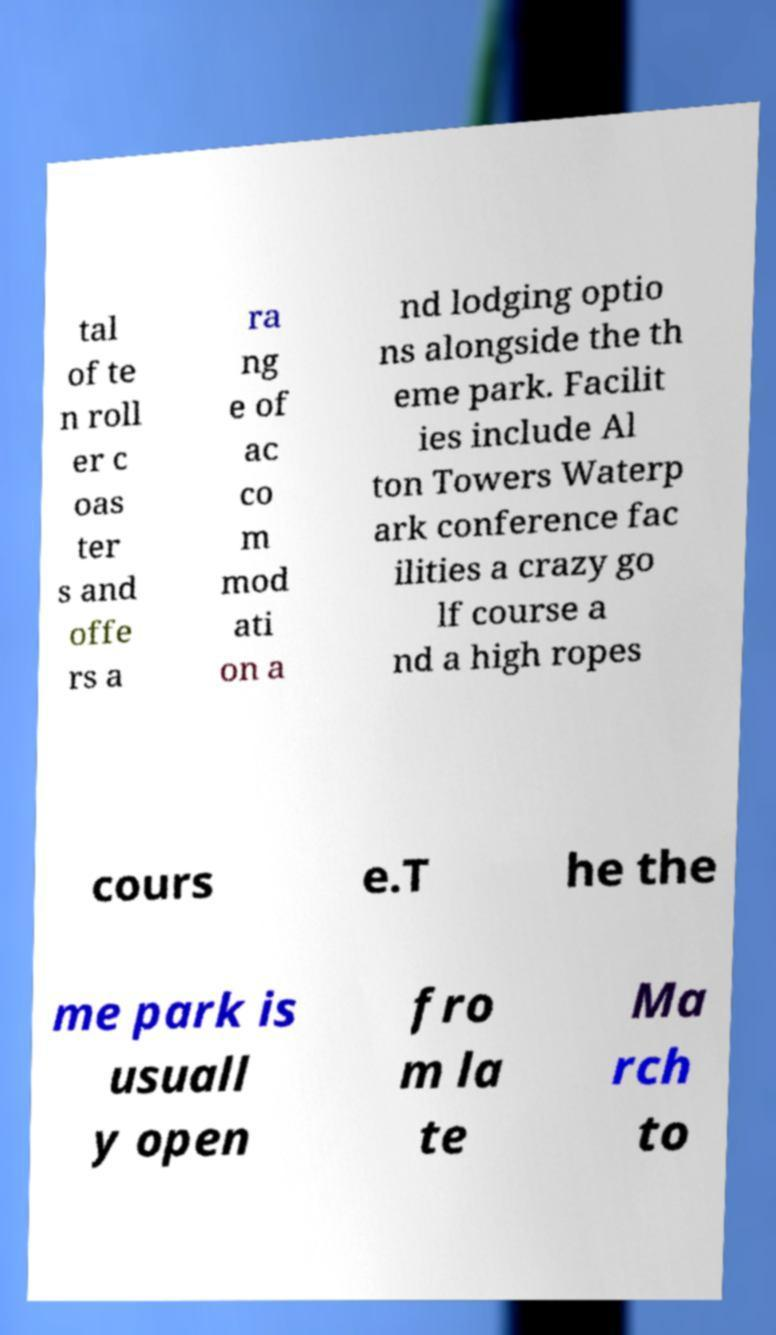Could you assist in decoding the text presented in this image and type it out clearly? tal of te n roll er c oas ter s and offe rs a ra ng e of ac co m mod ati on a nd lodging optio ns alongside the th eme park. Facilit ies include Al ton Towers Waterp ark conference fac ilities a crazy go lf course a nd a high ropes cours e.T he the me park is usuall y open fro m la te Ma rch to 